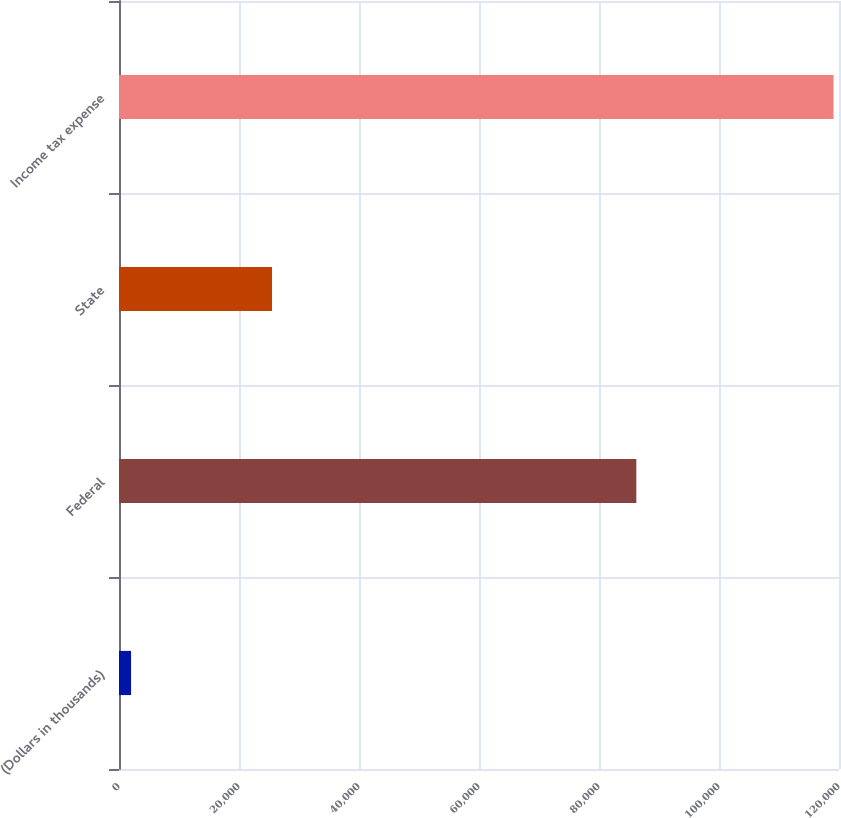Convert chart. <chart><loc_0><loc_0><loc_500><loc_500><bar_chart><fcel>(Dollars in thousands)<fcel>Federal<fcel>State<fcel>Income tax expense<nl><fcel>2011<fcel>86220<fcel>25505<fcel>119087<nl></chart> 